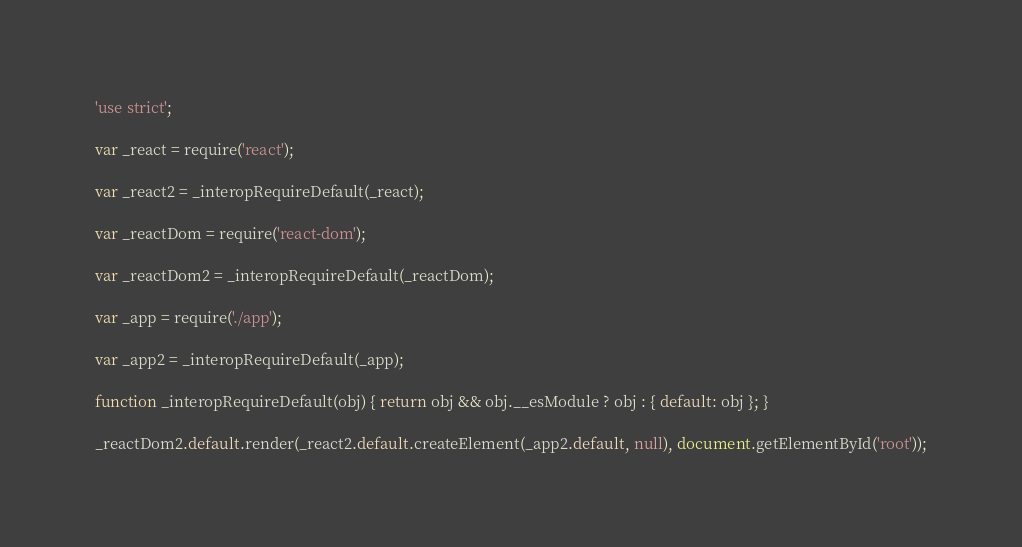<code> <loc_0><loc_0><loc_500><loc_500><_JavaScript_>'use strict';

var _react = require('react');

var _react2 = _interopRequireDefault(_react);

var _reactDom = require('react-dom');

var _reactDom2 = _interopRequireDefault(_reactDom);

var _app = require('./app');

var _app2 = _interopRequireDefault(_app);

function _interopRequireDefault(obj) { return obj && obj.__esModule ? obj : { default: obj }; }

_reactDom2.default.render(_react2.default.createElement(_app2.default, null), document.getElementById('root'));</code> 